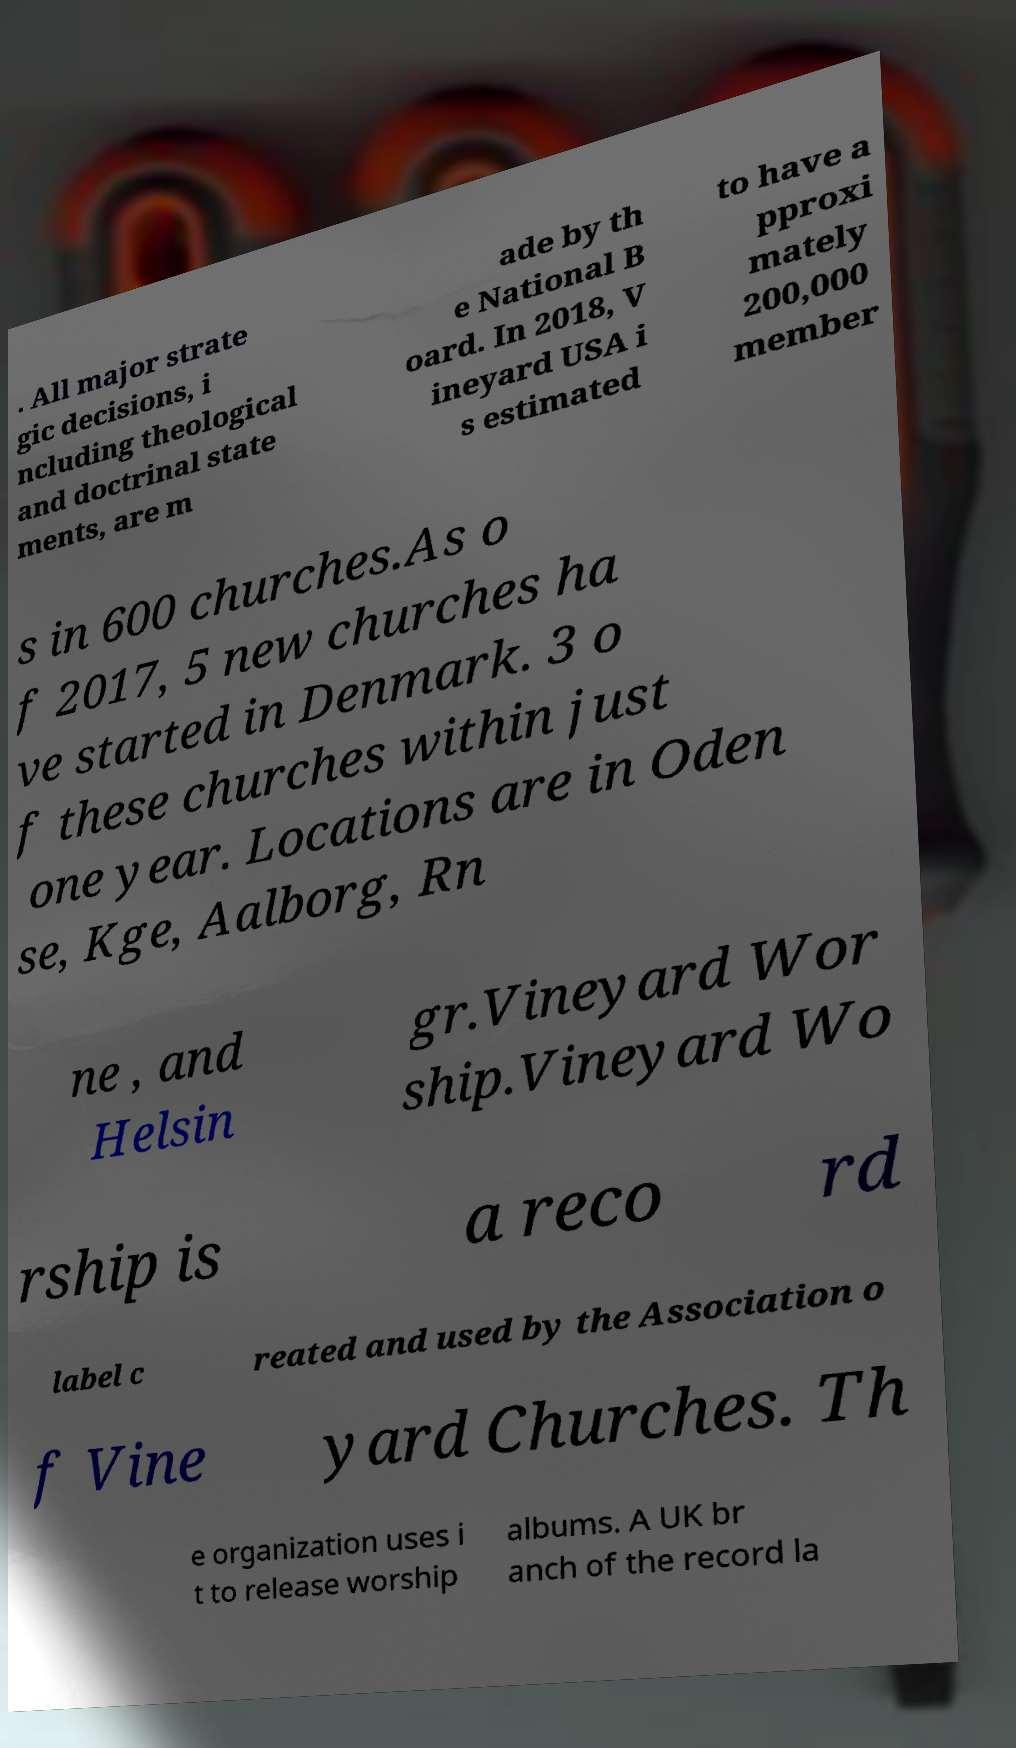Could you extract and type out the text from this image? . All major strate gic decisions, i ncluding theological and doctrinal state ments, are m ade by th e National B oard. In 2018, V ineyard USA i s estimated to have a pproxi mately 200,000 member s in 600 churches.As o f 2017, 5 new churches ha ve started in Denmark. 3 o f these churches within just one year. Locations are in Oden se, Kge, Aalborg, Rn ne , and Helsin gr.Vineyard Wor ship.Vineyard Wo rship is a reco rd label c reated and used by the Association o f Vine yard Churches. Th e organization uses i t to release worship albums. A UK br anch of the record la 